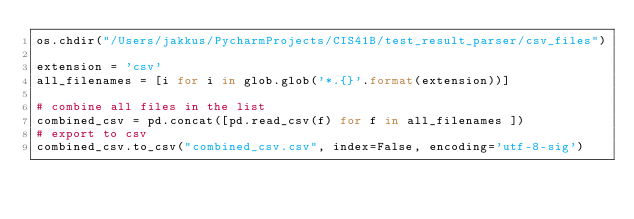<code> <loc_0><loc_0><loc_500><loc_500><_Python_>os.chdir("/Users/jakkus/PycharmProjects/CIS41B/test_result_parser/csv_files")

extension = 'csv'
all_filenames = [i for i in glob.glob('*.{}'.format(extension))]

# combine all files in the list
combined_csv = pd.concat([pd.read_csv(f) for f in all_filenames ])
# export to csv
combined_csv.to_csv("combined_csv.csv", index=False, encoding='utf-8-sig')


</code> 